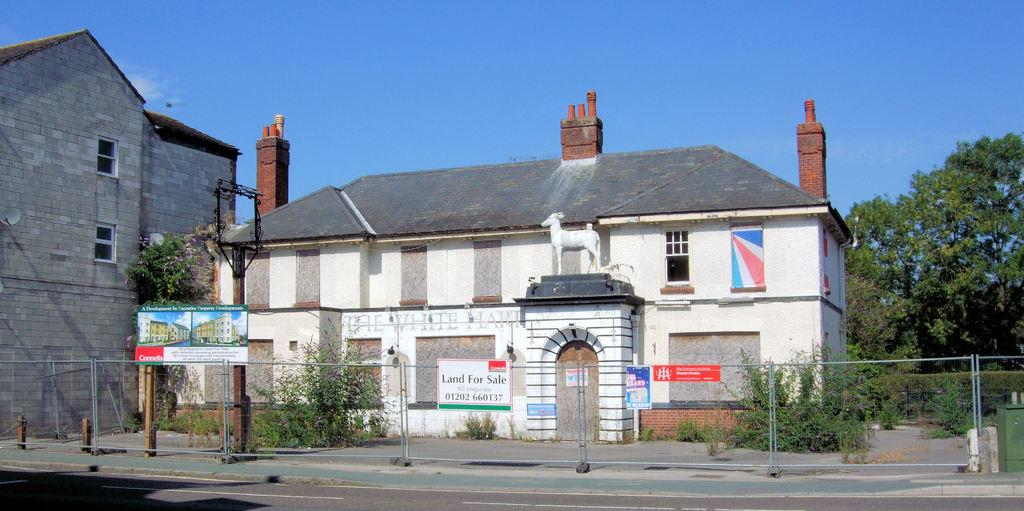What type of barrier can be seen in the image? There is a fence in the image. What living organisms are present in the image? There are plants, birds, and trees in the image. What type of structures can be seen in the image? There are houses in the image. What part of the natural environment is visible in the image? The sky is visible in the background of the image. What type of low selection can be seen in the image? There is no mention of a low selection in the image; the image features a fence, plants, birds, houses, trees, and the sky. What type of food is being prepared in the image? There is no indication of food preparation in the image. 